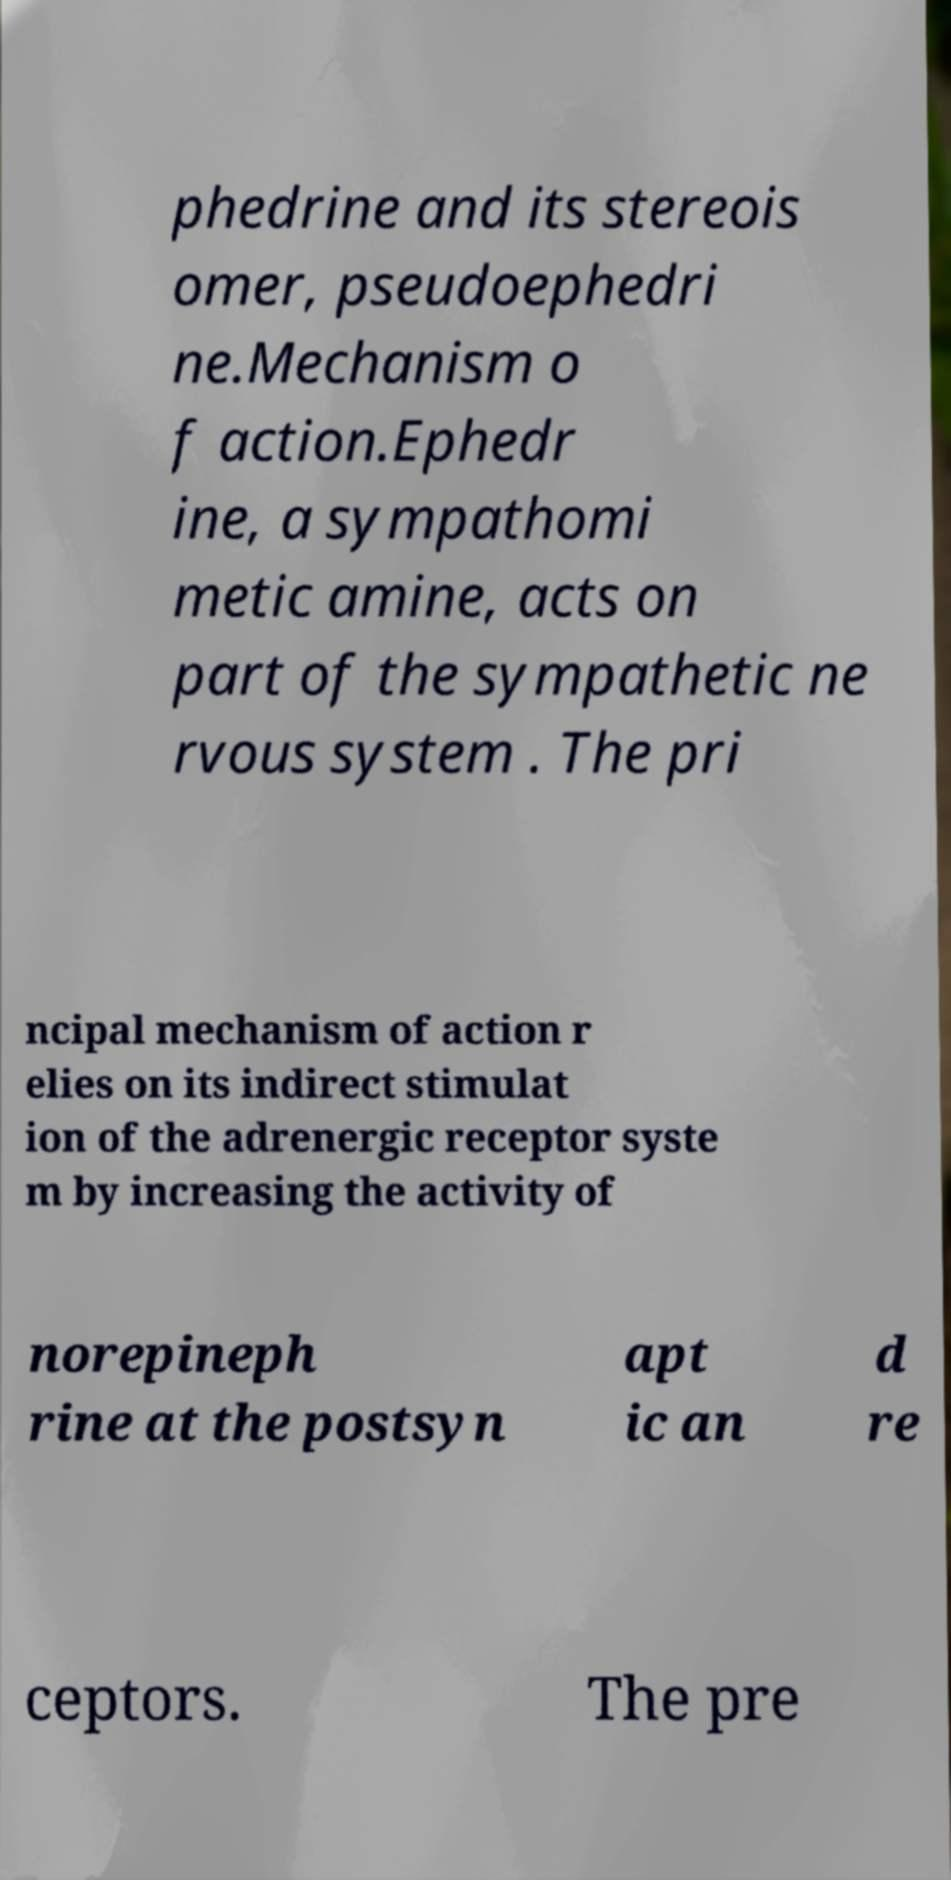For documentation purposes, I need the text within this image transcribed. Could you provide that? phedrine and its stereois omer, pseudoephedri ne.Mechanism o f action.Ephedr ine, a sympathomi metic amine, acts on part of the sympathetic ne rvous system . The pri ncipal mechanism of action r elies on its indirect stimulat ion of the adrenergic receptor syste m by increasing the activity of norepineph rine at the postsyn apt ic an d re ceptors. The pre 